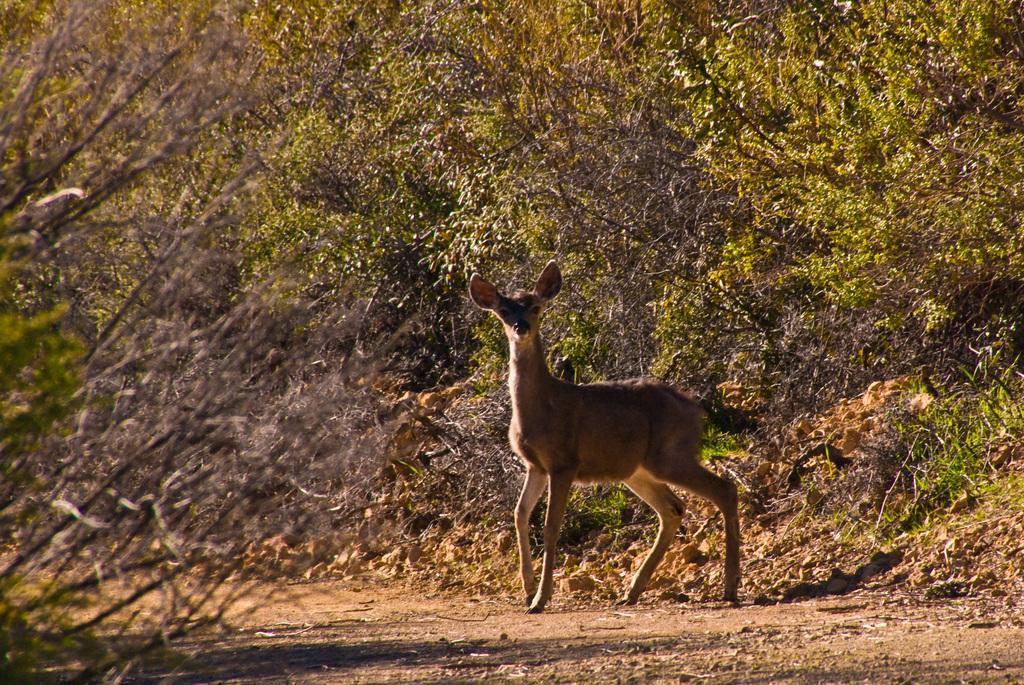How would you summarize this image in a sentence or two? There is a deer walking on the road on which, there are stones and small sticks. On the left side, there are dry plants. On the right side, there is grass, there are plants and trees on the hill. In the background, there are plants. 